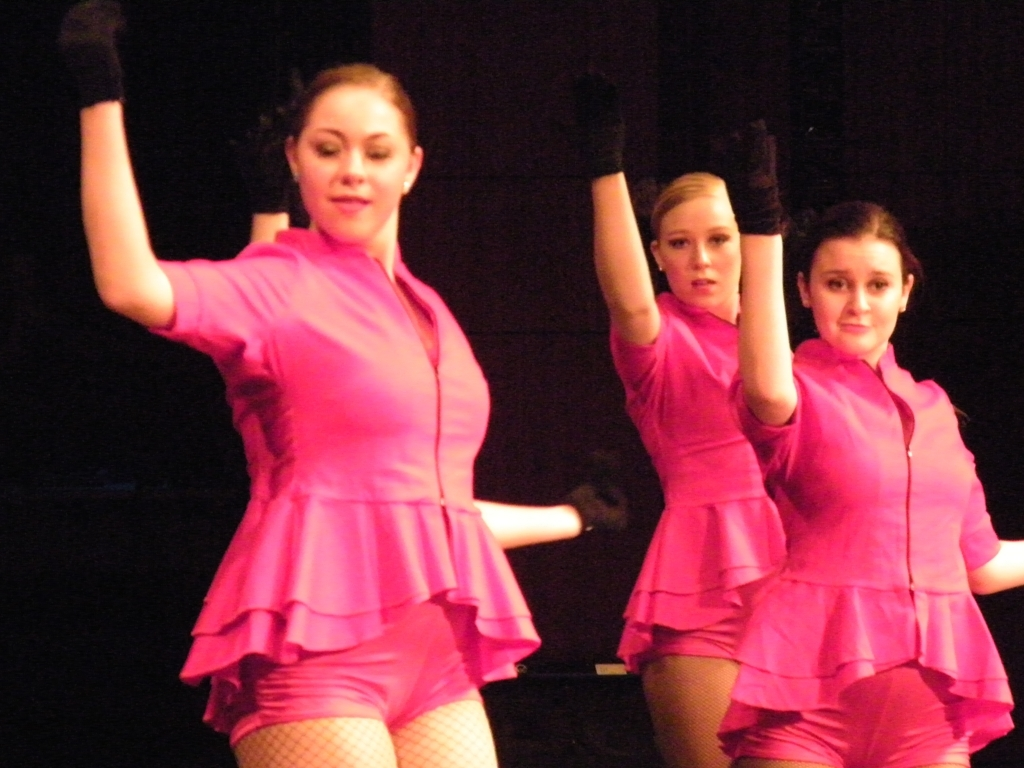Is there anything significant about their expressions? Expressions in dance are crucial for conveying the story or emotions intended by the choreography. These performers are focused, with their eyes projecting confidence and determination, which is often a hallmark of a strong, interpretative dance piece. 